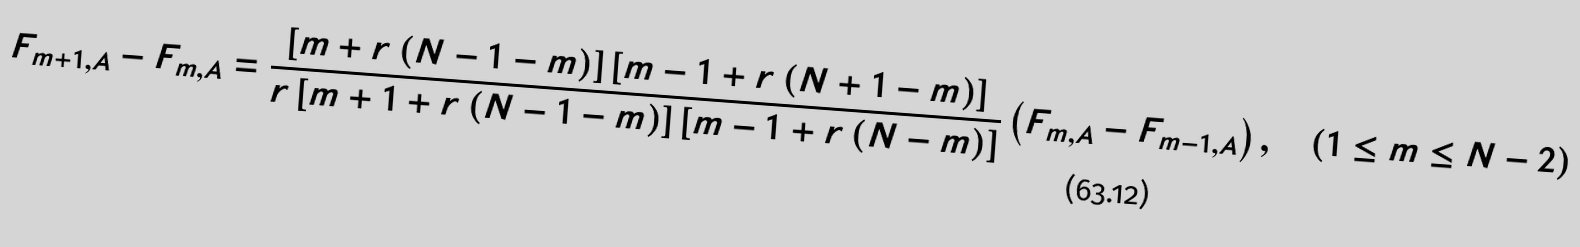Convert formula to latex. <formula><loc_0><loc_0><loc_500><loc_500>F _ { m + 1 , A } - F _ { m , A } = \frac { \left [ m + r \left ( N - 1 - m \right ) \right ] \left [ m - 1 + r \left ( N + 1 - m \right ) \right ] } { r \left [ m + 1 + r \left ( N - 1 - m \right ) \right ] \left [ m - 1 + r \left ( N - m \right ) \right ] } \left ( F _ { m , A } - F _ { m - 1 , A } \right ) , \quad ( 1 \leq m \leq N - 2 )</formula> 